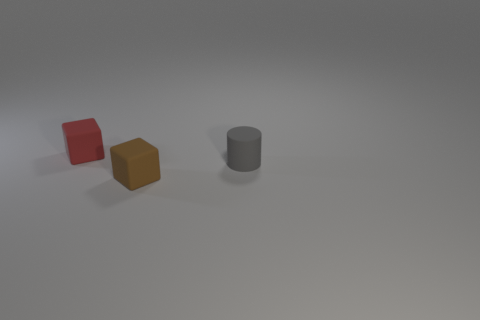Add 1 small cyan metal balls. How many objects exist? 4 Subtract all cubes. How many objects are left? 1 Add 2 small cylinders. How many small cylinders are left? 3 Add 3 gray matte cylinders. How many gray matte cylinders exist? 4 Subtract 0 yellow cylinders. How many objects are left? 3 Subtract all tiny brown metallic cubes. Subtract all gray things. How many objects are left? 2 